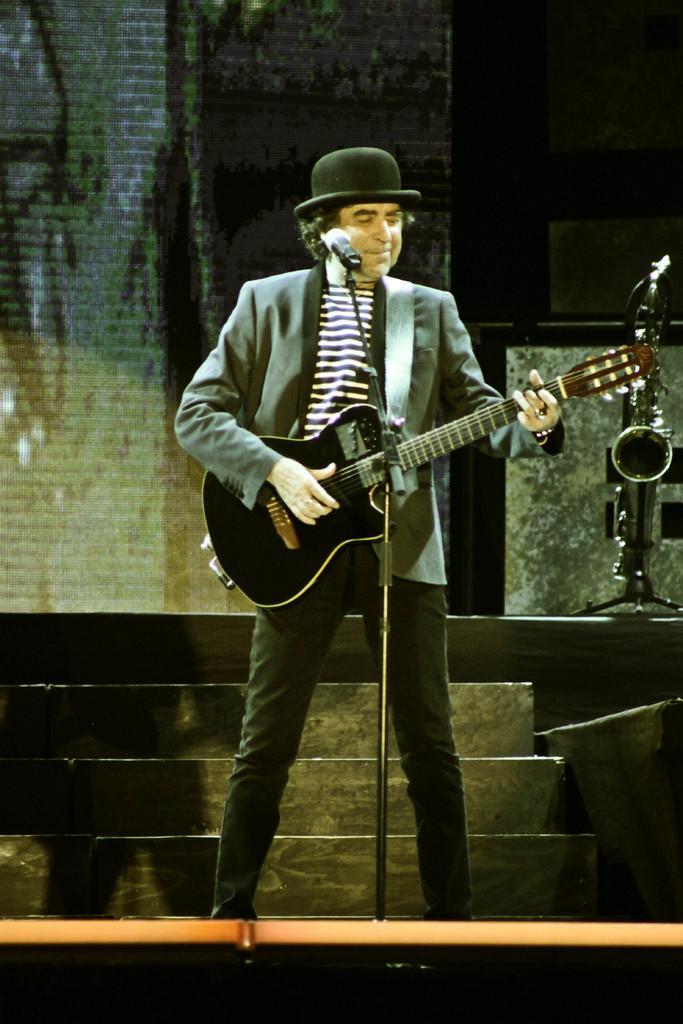Please provide a concise description of this image. In this image a man is standing on a stage. He is playing guitar. He is wearing a coat and a black hat. In front of him there is a mic. Beside him there is a trumpet on a stand. In the background there is a wall. 